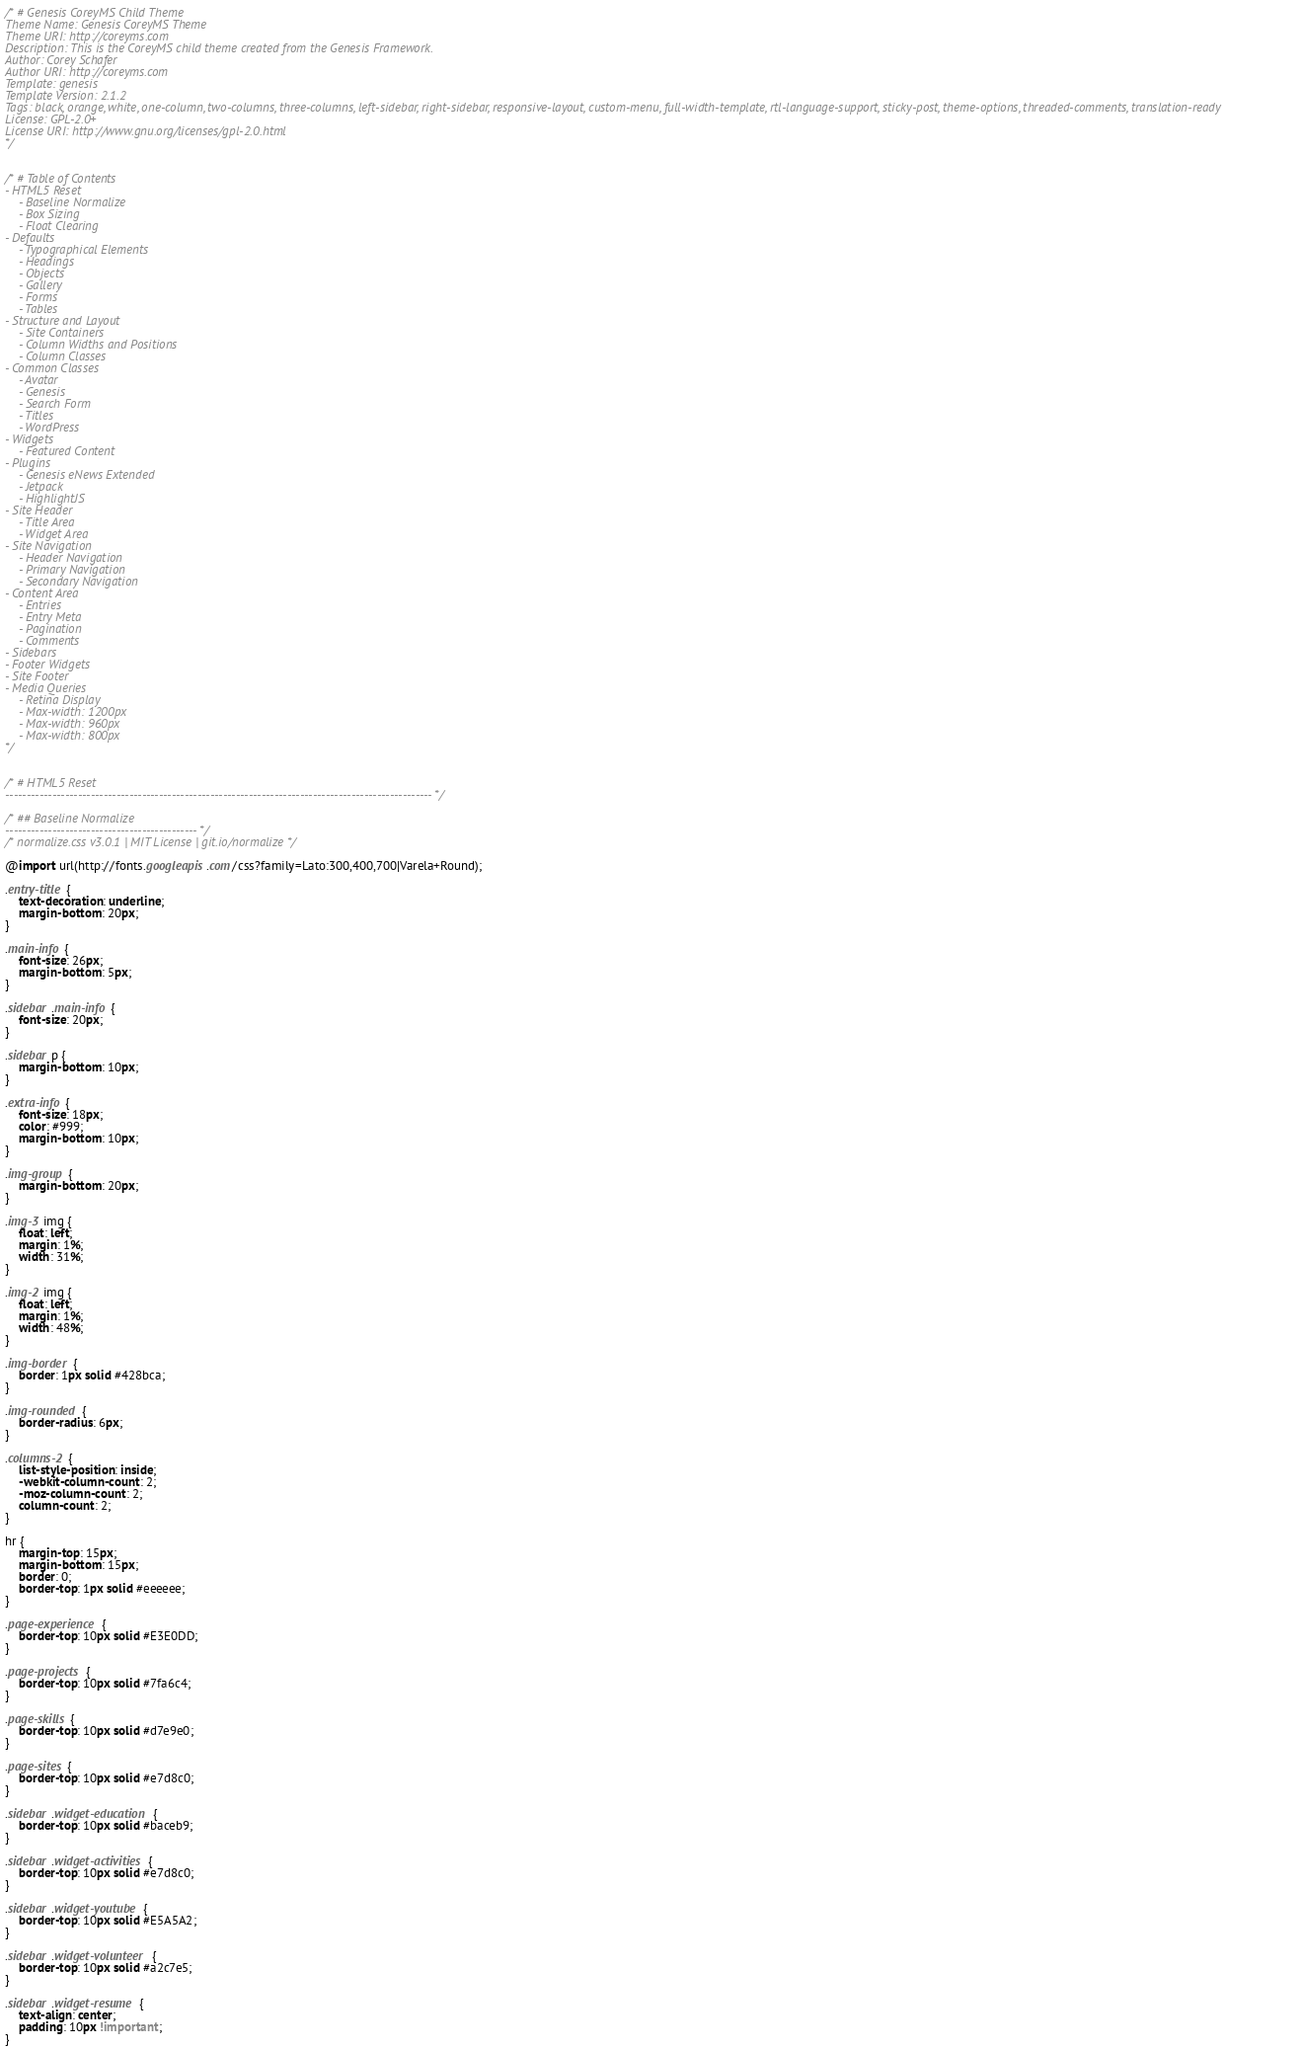Convert code to text. <code><loc_0><loc_0><loc_500><loc_500><_CSS_>/* # Genesis CoreyMS Child Theme
Theme Name: Genesis CoreyMS Theme
Theme URI: http://coreyms.com
Description: This is the CoreyMS child theme created from the Genesis Framework.
Author: Corey Schafer
Author URI: http://coreyms.com
Template: genesis
Template Version: 2.1.2
Tags: black, orange, white, one-column, two-columns, three-columns, left-sidebar, right-sidebar, responsive-layout, custom-menu, full-width-template, rtl-language-support, sticky-post, theme-options, threaded-comments, translation-ready
License: GPL-2.0+
License URI: http://www.gnu.org/licenses/gpl-2.0.html
*/


/* # Table of Contents
- HTML5 Reset
	- Baseline Normalize
	- Box Sizing
	- Float Clearing
- Defaults
	- Typographical Elements
	- Headings
	- Objects
	- Gallery
	- Forms
	- Tables
- Structure and Layout
	- Site Containers
	- Column Widths and Positions
	- Column Classes
- Common Classes
	- Avatar
	- Genesis
	- Search Form
	- Titles
	- WordPress
- Widgets
	- Featured Content
- Plugins
	- Genesis eNews Extended
	- Jetpack
	- HighlightJS
- Site Header
	- Title Area
	- Widget Area
- Site Navigation
	- Header Navigation
	- Primary Navigation
	- Secondary Navigation
- Content Area
	- Entries
	- Entry Meta
	- Pagination
	- Comments
- Sidebars
- Footer Widgets
- Site Footer
- Media Queries
	- Retina Display
	- Max-width: 1200px
	- Max-width: 960px
	- Max-width: 800px
*/


/* # HTML5 Reset
---------------------------------------------------------------------------------------------------- */

/* ## Baseline Normalize
--------------------------------------------- */
/* normalize.css v3.0.1 | MIT License | git.io/normalize */

@import url(http://fonts.googleapis.com/css?family=Lato:300,400,700|Varela+Round);

.entry-title {
    text-decoration: underline;
    margin-bottom: 20px;
}

.main-info {
    font-size: 26px;
    margin-bottom: 5px;
}

.sidebar .main-info {
    font-size: 20px;
}

.sidebar p {
    margin-bottom: 10px;
}

.extra-info {
    font-size: 18px;
    color: #999;
    margin-bottom: 10px;
}

.img-group {
    margin-bottom: 20px;
}

.img-3 img {
    float: left;
    margin: 1%;
    width: 31%;
}

.img-2 img {
    float: left;
    margin: 1%;
    width: 48%;
}

.img-border {
    border: 1px solid #428bca;
}

.img-rounded {
    border-radius: 6px;
}

.columns-2 {
    list-style-position: inside;
    -webkit-column-count: 2;
    -moz-column-count: 2;
    column-count: 2;
}

hr {
    margin-top: 15px;
    margin-bottom: 15px;
    border: 0;
    border-top: 1px solid #eeeeee;
}

.page-experience {
    border-top: 10px solid #E3E0DD;
}

.page-projects {
    border-top: 10px solid #7fa6c4;
}

.page-skills {
    border-top: 10px solid #d7e9e0;
}

.page-sites {
    border-top: 10px solid #e7d8c0;
}

.sidebar .widget-education {
    border-top: 10px solid #baceb9;
}

.sidebar .widget-activities {
    border-top: 10px solid #e7d8c0;
}

.sidebar .widget-youtube {
    border-top: 10px solid #E5A5A2;
}

.sidebar .widget-volunteer {
    border-top: 10px solid #a2c7e5;
}

.sidebar .widget-resume {
    text-align: center;
    padding: 10px !important;
}
</code> 